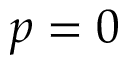Convert formula to latex. <formula><loc_0><loc_0><loc_500><loc_500>p = 0</formula> 